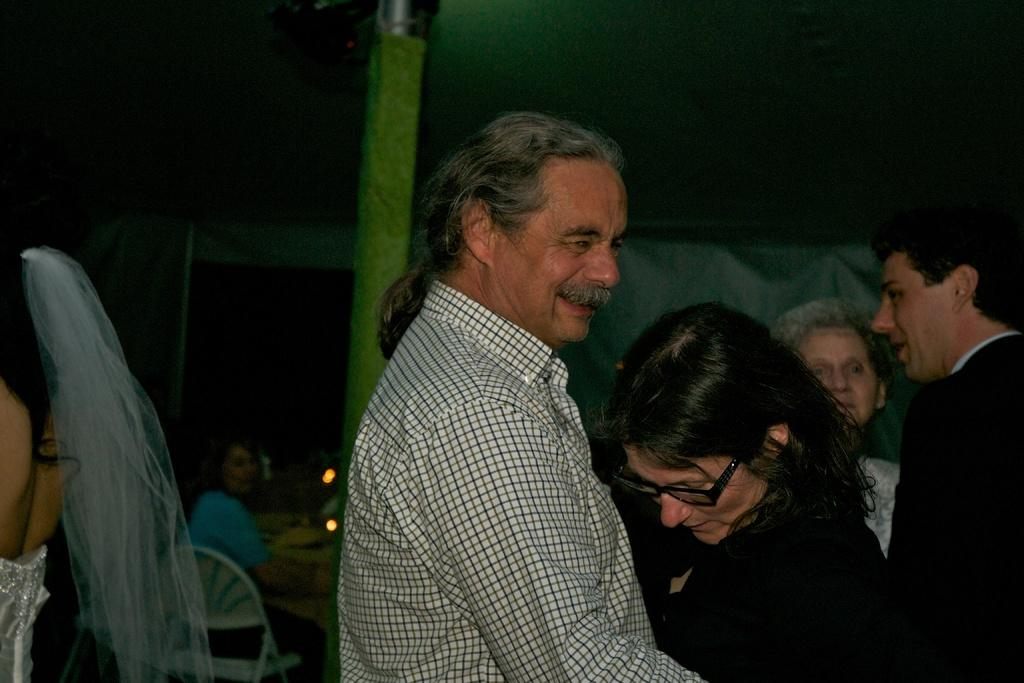What are the people in the image doing? There are people standing in the image. Can you describe the people in the background? In the background, there are people sitting on chairs. What object can be seen in the image that has a roof at the top? There is a pole in the image, and at the top of the pole, there is a roof. What type of badge is being worn by the crowd in the image? There is no crowd present in the image, and no badges are visible on any of the people. 